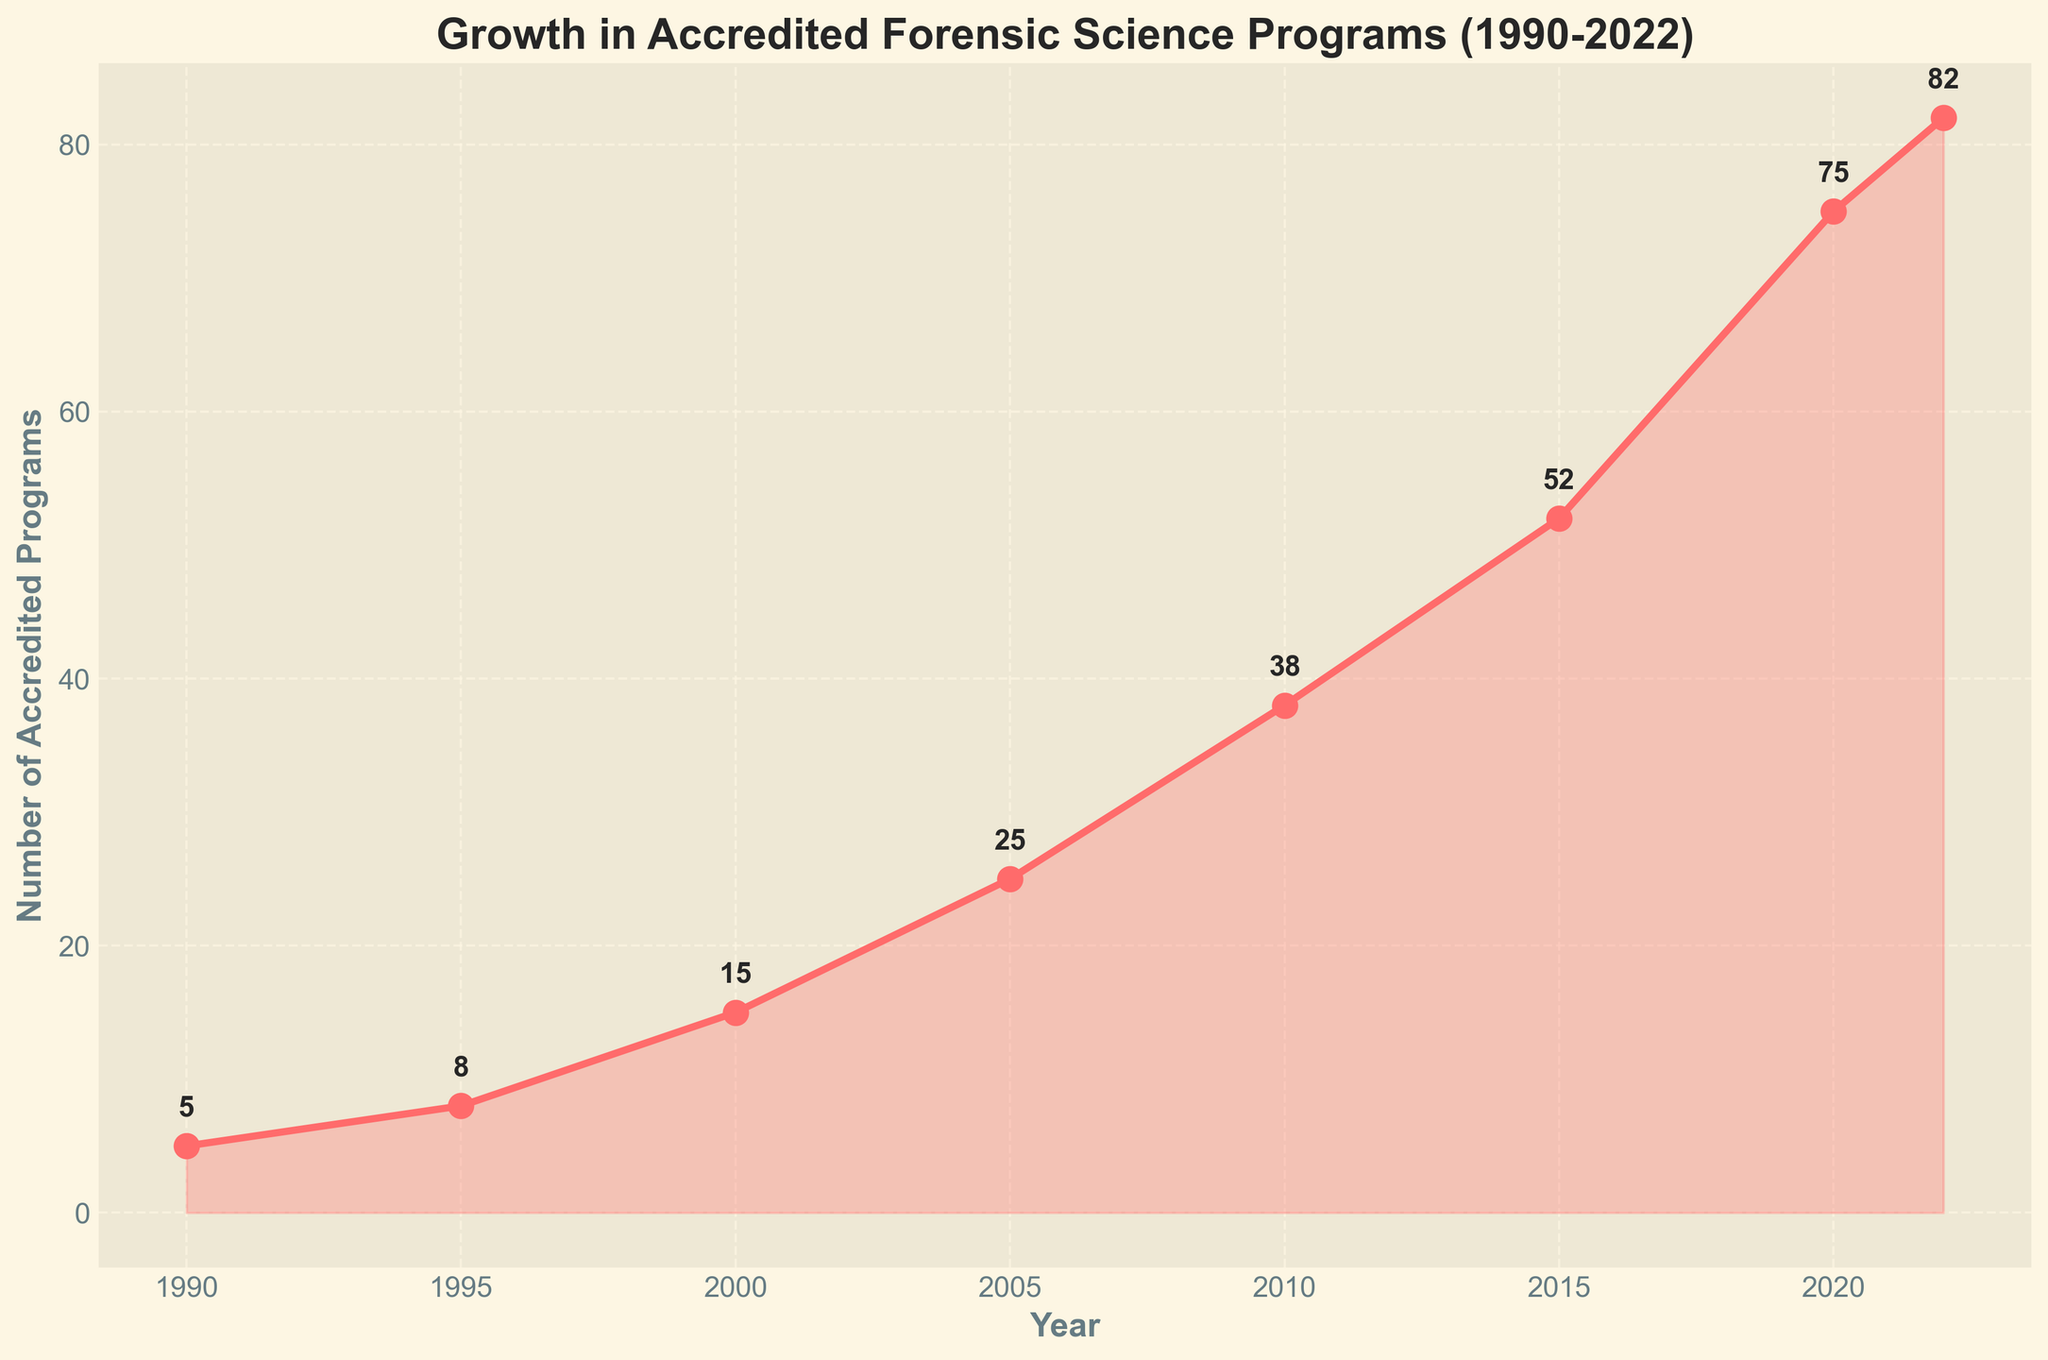what trend do you observe in the number of accredited forensic science programs from 1990 to 2022? By examining the line chart, we observe a generally upward trend in the number of accredited forensic science programs, with noticeable increases at multiple points in time. The growth starts at 5 programs in 1990 and reaches 82 programs by 2022.
Answer: Upward trend In what year was the number of accredited forensic science programs the highest, and what was that number? The year with the highest number of accredited forensic science programs can be observed at the end of the line chart. In 2022, the number of accredited programs is 82.
Answer: 2022, 82 How many more accredited forensic science programs were there in 2010 compared to 2000? The number of programs in 2010 is 38 and in 2000 is 15. Subtracting these values gives 38 - 15 = 23 more programs in 2010 compared to 2000.
Answer: 23 What is the average growth in the number of new accredited forensic science programs every 5 years between 1990 and 2015? The number of programs in 1990 is 5, in 1995 is 8, in 2000 is 15, in 2005 is 25, in 2010 is 38, and in 2015 is 52. The total growth over these periods is (8-5) + (15-8) + (25-15) + (38-25) + (52-38) = 3 + 7 + 10 + 13 + 14 = 47. Dividing this by 5 gives 47/5 = 9.4.
Answer: 9.4 Which period saw the largest increase in the number of accredited programs? By comparing the differences between consecutive years, 2015 to 2020 saw the largest increase: (75 - 52) = 23 programs. The increments for other periods are smaller compared to this.
Answer: 2015 to 2020 Between 1990 and 2005, how many total accredited forensic science programs were added? Summing the differences over this period: (8 - 5) + (15 - 8) + (25 - 15) = 3 + 7 + 10 = 20 programs added between 1990 and 2005.
Answer: 20 What is the slope of the trend line from 2015 to 2022? The slope can be determined by calculating the change in the number of programs divided by the change in years between 2015 and 2022. Slope = (82 - 52) / (2022 - 2015) = 30 / 7 ≈ 4.29 programs per year.
Answer: 4.29 How does the growth rate in the number of programs between 2000 and 2005 compare to the growth rate between 1995 and 2000? For 2000 to 2005, the rate is (25 - 15) / (2005 - 2000) = 10 / 5 = 2 programs per year. For 1995 to 2000, the rate is (15 - 8) / (2000 - 1995) = 7 / 5 = 1.4 programs per year. The growth rate from 2000 to 2005 is higher.
Answer: 2000–2005 is higher Describe the visual trend for the number of accredited forensic science programs between 2010 and 2022. The pattern is a rising trend where the number of programs increases significantly. The line becomes steeper, indicating accelerated growth. Specifically, it rises from 38 in 2010 to 82 in 2022.
Answer: Accelerated growth How many years saw an increase of more than 10 accredited forensic science programs compared to the previous recorded year? Observing the increases year by year: 2000 to 2005 (10), 2005 to 2010 (13), and 2015 to 2020 (23) saw increases greater than 10. Thus, 3 periods meet the criterion.
Answer: 3 